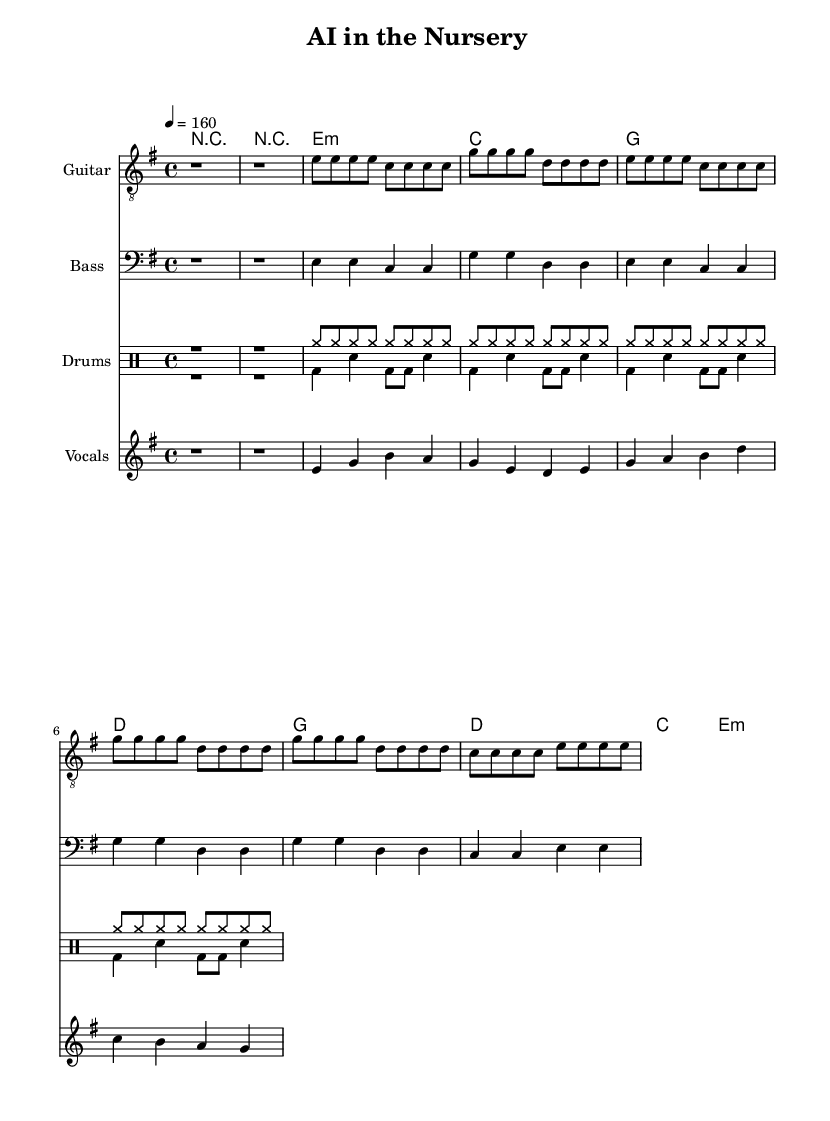What is the key signature of this music? The key signature is E minor, which has one sharp (F#). This can be identified at the beginning of the sheet music.
Answer: E minor What is the time signature of this piece? The time signature is 4/4, which means there are four beats in each measure. This is typically indicated at the beginning of the music.
Answer: 4/4 What is the tempo marking of this music? The tempo marking is quarter note equals 160 beats per minute, meaning the speed of the piece is quite fast. This is denoted in the tempo section of the music.
Answer: 160 How many measures are in the chorus? The chorus consists of four measures, which can be counted by looking at the sections marked "Chorus" in the sheet music along with the notation that reflects the duration.
Answer: 4 What type of rhythm do the drums primarily use in the introduction? The drums primarily use a cymbal rhythm in the introduction, marked by cymbals in the drum notation section.
Answer: Cymbals What is the overall thematic focus of the lyrics? The thematic focus of the lyrics centers around the ethical implications of AI in pediatric care, as indicated by phrases that suggest questioning and the environment of a pediatric ward.
Answer: Ethical implications What kind of guitar chords are used in the verse? The guitar chords used in the verse include minor and major chords, specifically E minor, C major, G major, and D major, indicating a range of tonalities in punk music.
Answer: E minor, C, G, D 